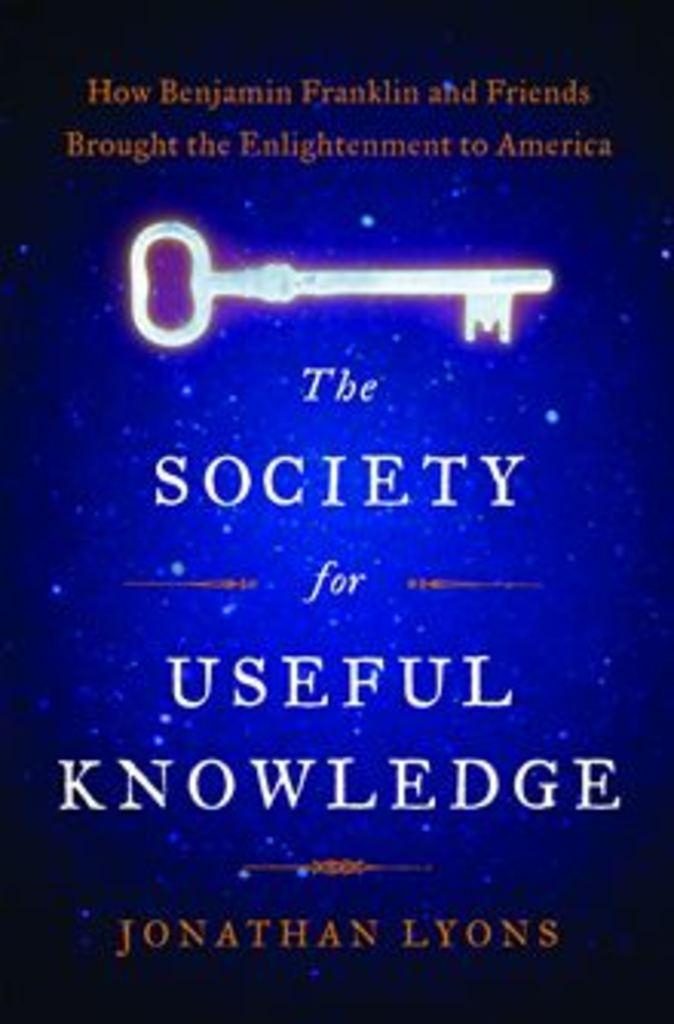<image>
Share a concise interpretation of the image provided. A blue book called The Society for Useful Knowledge 